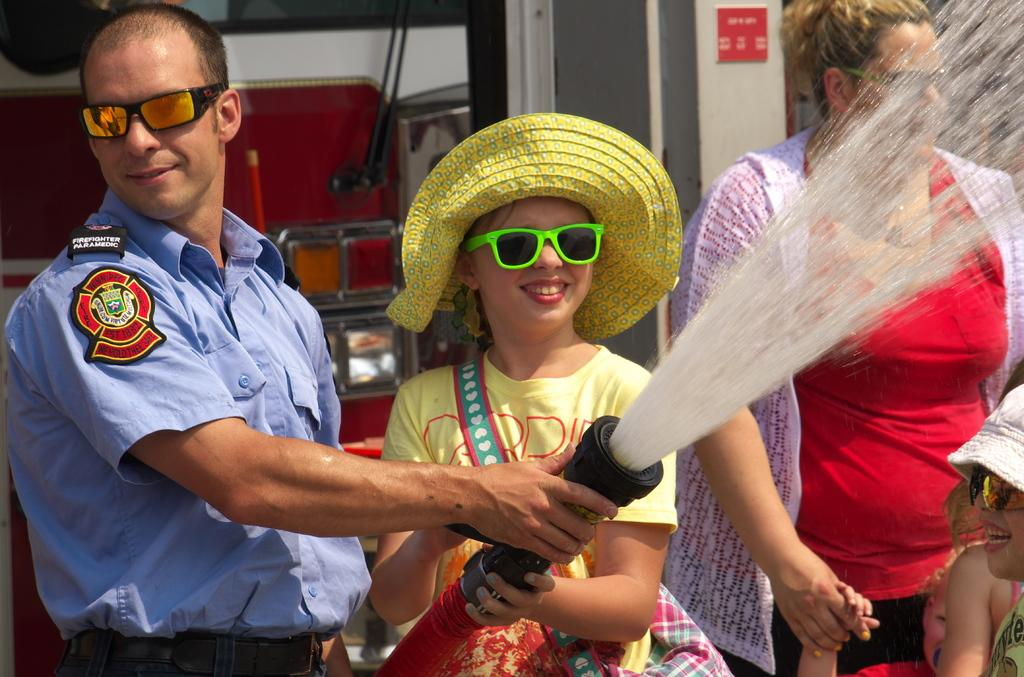Who is present in the image? There is a girl and an officer in the image. What is the officer holding? The officer is holding a water pipe. Who is standing beside the girl? There is a woman standing beside the girl. What can be seen behind the girl? There is a fire truck behind the girl. What type of alley can be seen in the image? There is no alley present in the image. Can you provide a list of the items the girl is holding in the image? The girl is not holding any items in the image, so there is no list to provide. 